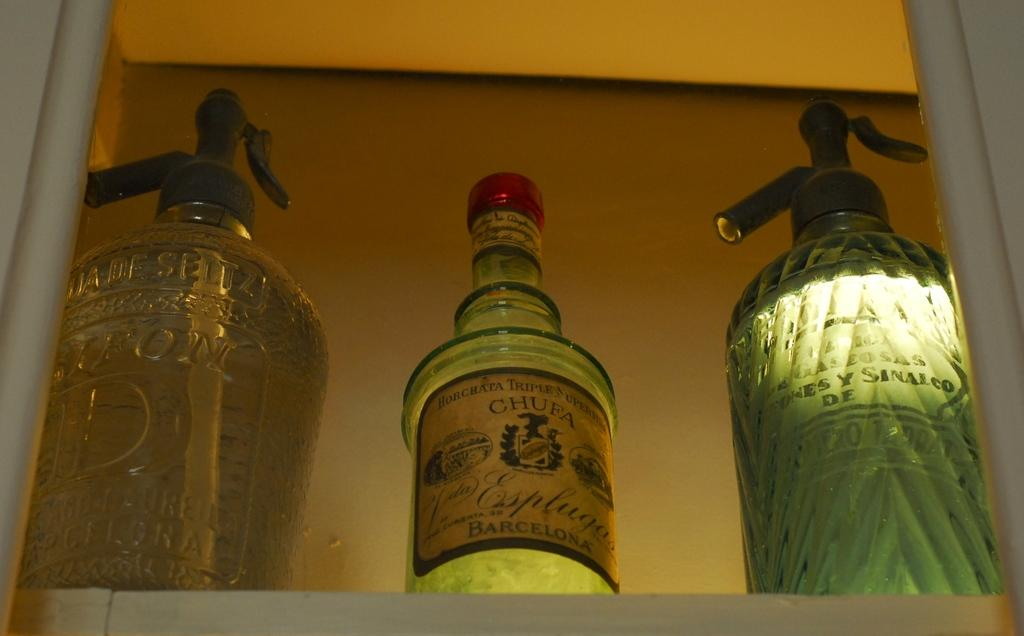How many bottles are visible in the image? There are three bottles in the image. What can be seen in the background of the image? There is a wall in the background of the image. What type of secretary can be seen working in the image? There is no secretary present in the image; it only features three bottles and a wall in the background. 